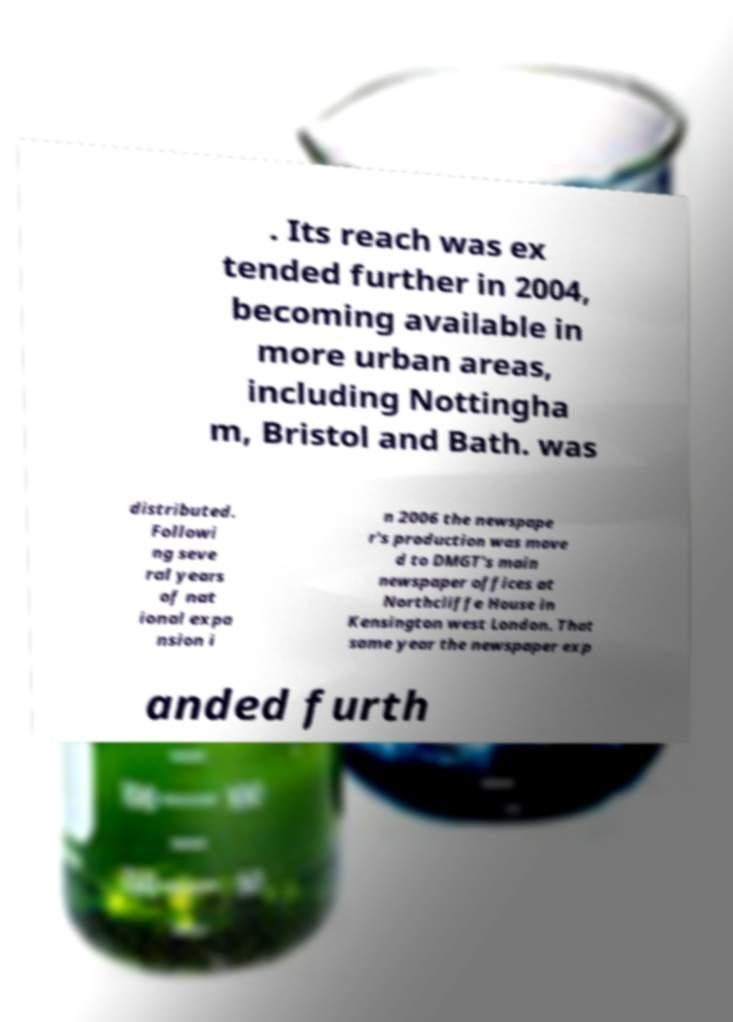What messages or text are displayed in this image? I need them in a readable, typed format. . Its reach was ex tended further in 2004, becoming available in more urban areas, including Nottingha m, Bristol and Bath. was distributed. Followi ng seve ral years of nat ional expa nsion i n 2006 the newspape r's production was move d to DMGT's main newspaper offices at Northcliffe House in Kensington west London. That same year the newspaper exp anded furth 